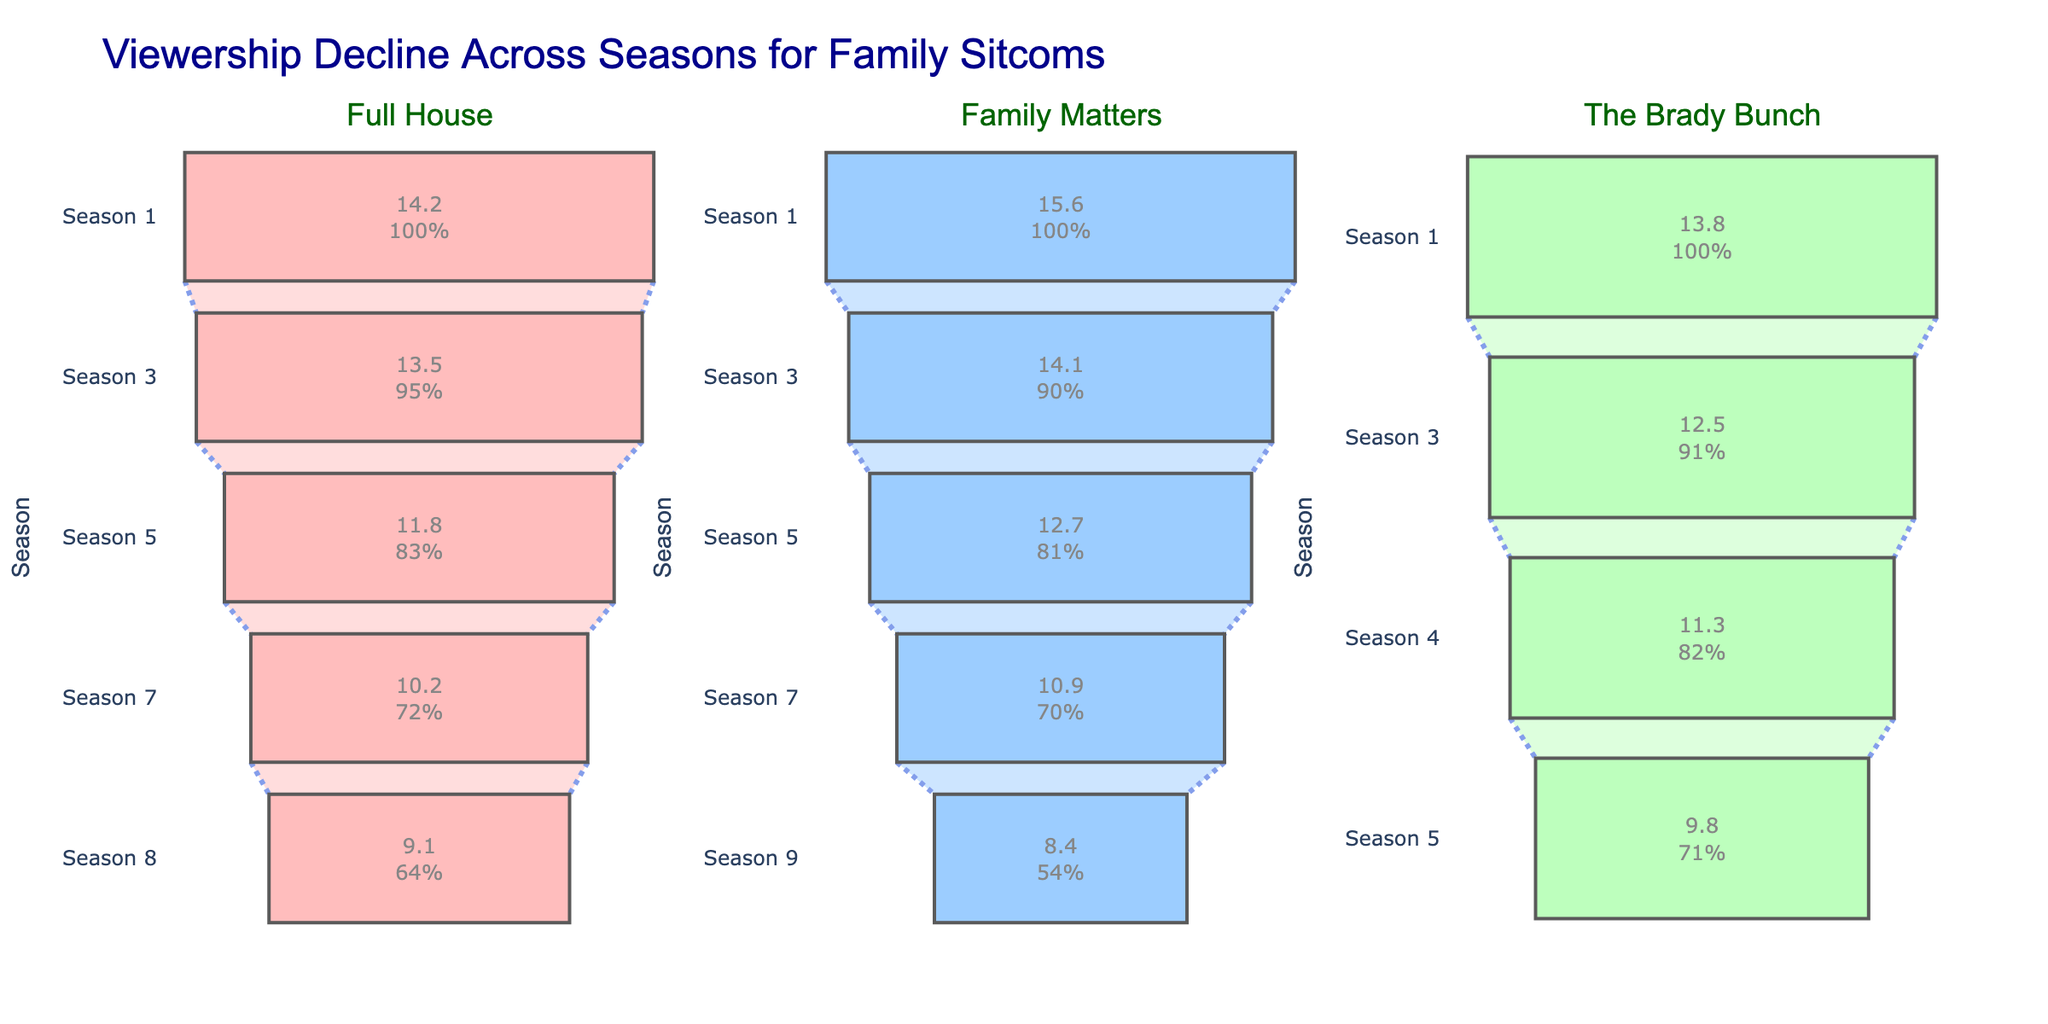What's the title of the figure? The title is clearly displayed at the top of the figure.
Answer: Viewership Decline Across Seasons for Family Sitcoms How many family sitcoms are being analyzed in the figure? The figure has three subplot titles, each representing a different family sitcom.
Answer: 3 Which sitcom has the highest average viewership in its first season? By comparing the values for "Season 1" across all three subplots, "Family Matters" has the highest viewership in its first season with 15.6 million viewers.
Answer: Family Matters What is the average viewership decline from Season 1 to the last season for "Full House"? "Full House" had 14.2 million viewers in Season 1 and 9.1 million in Season 8. The decline is: 14.2 - 9.1 = 5.1 million.
Answer: 5.1 million Which show saw the largest overall decline in viewership across its seasons? Calculate the decline for each show: "Full House" (14.2 - 9.1 = 5.1 million), "Family Matters" (15.6 - 8.4 = 7.2 million), "The Brady Bunch" (13.8 - 9.8 = 4.0 million). "Family Matters" had the largest decline.
Answer: Family Matters Comparing Season 3 viewership, which show had more viewers, "Full House" or "The Brady Bunch"? For "Season 3," "Full House" had 13.5 million viewers while "The Brady Bunch" had 12.5 million. Therefore, "Full House" had more viewers.
Answer: Full House What percentage decline in viewership did "Family Matters" experience from Season 7 to Season 9? "Family Matters" had 10.9 million viewers in Season 7 and 8.4 million in Season 9. The decline in millions is 10.9 - 8.4 = 2.5. To find the percentage: (2.5 / 10.9) * 100 ≈ 22.94%.
Answer: Approximately 22.94% Which show maintained the most consistent viewership across its seasons? Looking at the range of viewership declines, "The Brady Bunch" seems to have the least fluctuation between its highest (13.8 million) and lowest (9.8 million) viewership, i.e., a decline of 4.0 million.
Answer: The Brady Bunch How many seasons of data are shown for "Full House"? By counting the number of "Season" entries for "Full House," there are 5 data points: Seasons 1, 3, 5, 7, and 8.
Answer: 5 